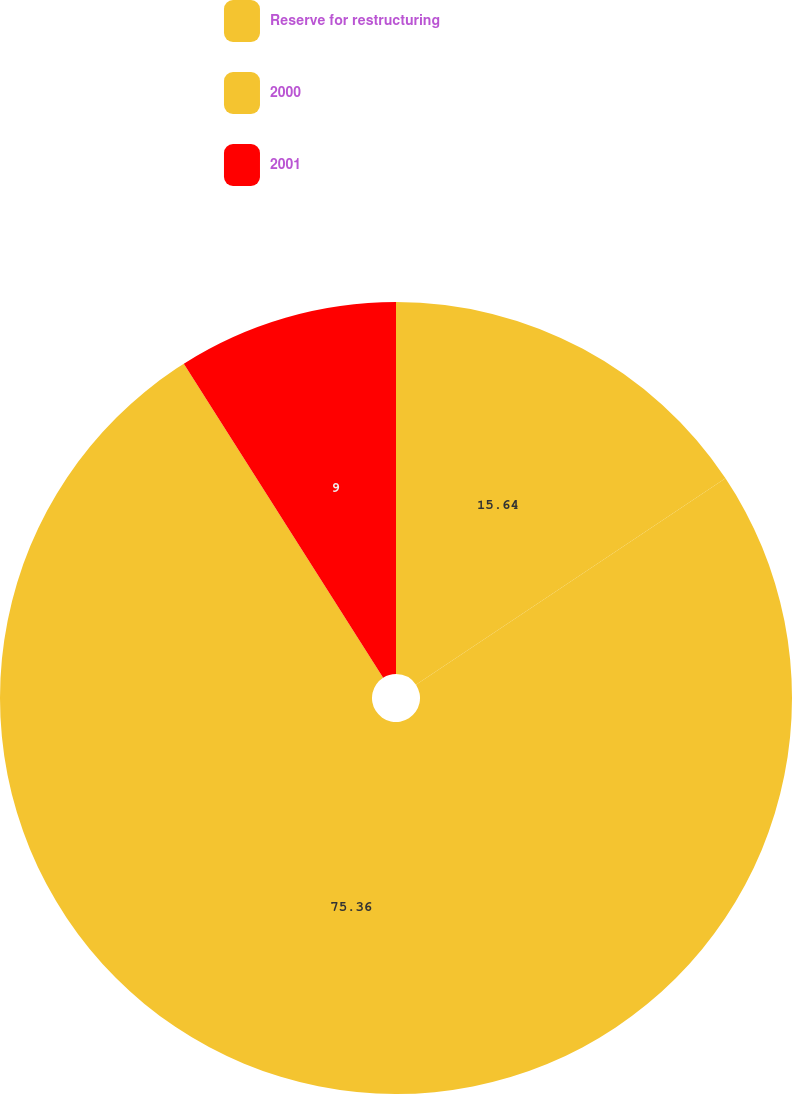<chart> <loc_0><loc_0><loc_500><loc_500><pie_chart><fcel>Reserve for restructuring<fcel>2000<fcel>2001<nl><fcel>15.64%<fcel>75.36%<fcel>9.0%<nl></chart> 